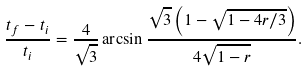<formula> <loc_0><loc_0><loc_500><loc_500>\frac { t _ { f } - t _ { i } } { t _ { i } } = \frac { 4 } { \sqrt { 3 } } \arcsin \frac { \sqrt { 3 } \left ( 1 - \sqrt { 1 - 4 r / 3 } \right ) } { 4 \sqrt { 1 - r } } .</formula> 